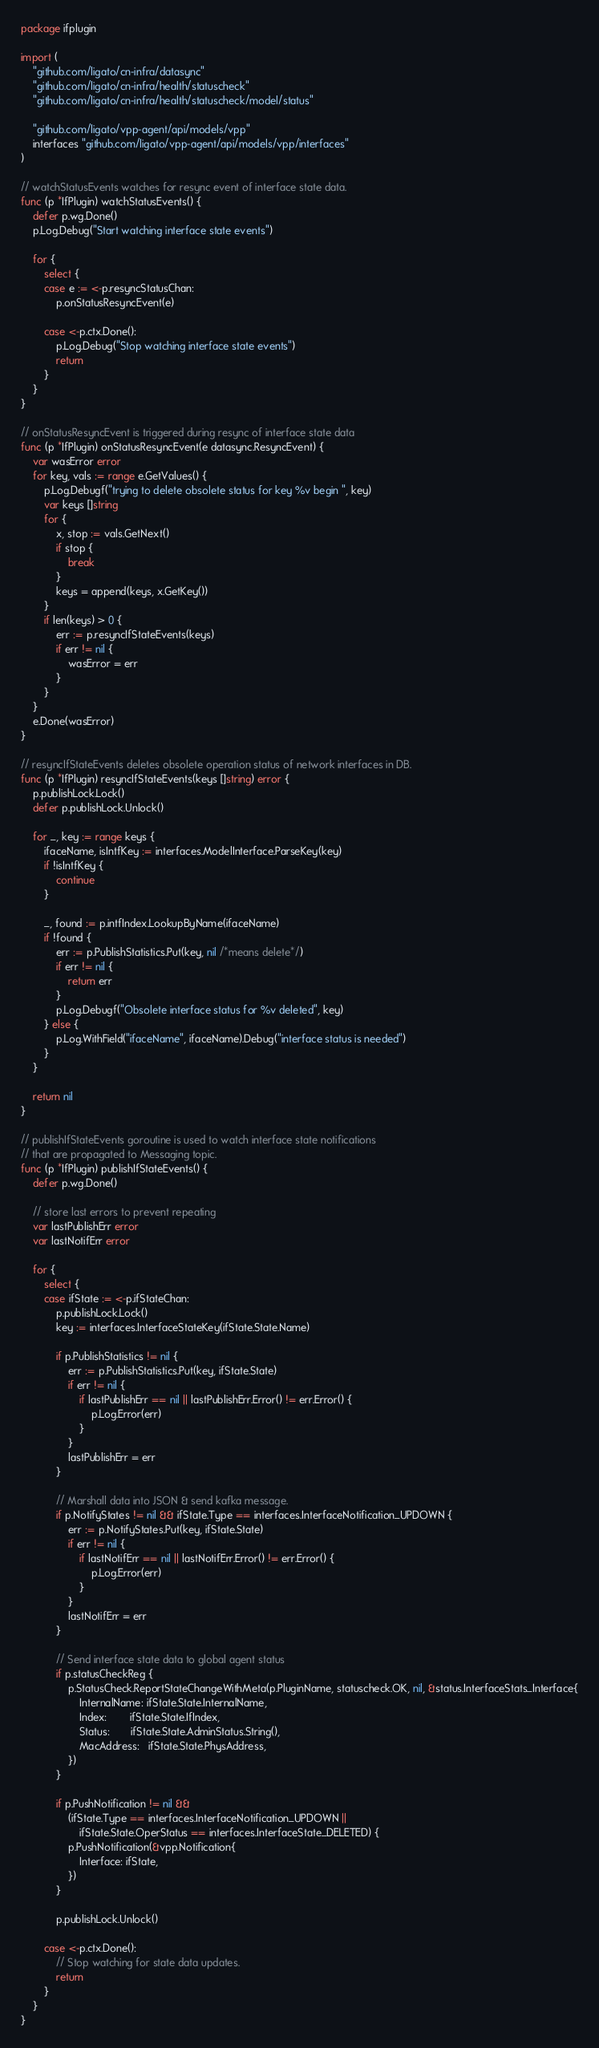Convert code to text. <code><loc_0><loc_0><loc_500><loc_500><_Go_>package ifplugin

import (
	"github.com/ligato/cn-infra/datasync"
	"github.com/ligato/cn-infra/health/statuscheck"
	"github.com/ligato/cn-infra/health/statuscheck/model/status"

	"github.com/ligato/vpp-agent/api/models/vpp"
	interfaces "github.com/ligato/vpp-agent/api/models/vpp/interfaces"
)

// watchStatusEvents watches for resync event of interface state data.
func (p *IfPlugin) watchStatusEvents() {
	defer p.wg.Done()
	p.Log.Debug("Start watching interface state events")

	for {
		select {
		case e := <-p.resyncStatusChan:
			p.onStatusResyncEvent(e)

		case <-p.ctx.Done():
			p.Log.Debug("Stop watching interface state events")
			return
		}
	}
}

// onStatusResyncEvent is triggered during resync of interface state data
func (p *IfPlugin) onStatusResyncEvent(e datasync.ResyncEvent) {
	var wasError error
	for key, vals := range e.GetValues() {
		p.Log.Debugf("trying to delete obsolete status for key %v begin ", key)
		var keys []string
		for {
			x, stop := vals.GetNext()
			if stop {
				break
			}
			keys = append(keys, x.GetKey())
		}
		if len(keys) > 0 {
			err := p.resyncIfStateEvents(keys)
			if err != nil {
				wasError = err
			}
		}
	}
	e.Done(wasError)
}

// resyncIfStateEvents deletes obsolete operation status of network interfaces in DB.
func (p *IfPlugin) resyncIfStateEvents(keys []string) error {
	p.publishLock.Lock()
	defer p.publishLock.Unlock()

	for _, key := range keys {
		ifaceName, isIntfKey := interfaces.ModelInterface.ParseKey(key)
		if !isIntfKey {
			continue
		}

		_, found := p.intfIndex.LookupByName(ifaceName)
		if !found {
			err := p.PublishStatistics.Put(key, nil /*means delete*/)
			if err != nil {
				return err
			}
			p.Log.Debugf("Obsolete interface status for %v deleted", key)
		} else {
			p.Log.WithField("ifaceName", ifaceName).Debug("interface status is needed")
		}
	}

	return nil
}

// publishIfStateEvents goroutine is used to watch interface state notifications
// that are propagated to Messaging topic.
func (p *IfPlugin) publishIfStateEvents() {
	defer p.wg.Done()

	// store last errors to prevent repeating
	var lastPublishErr error
	var lastNotifErr error

	for {
		select {
		case ifState := <-p.ifStateChan:
			p.publishLock.Lock()
			key := interfaces.InterfaceStateKey(ifState.State.Name)

			if p.PublishStatistics != nil {
				err := p.PublishStatistics.Put(key, ifState.State)
				if err != nil {
					if lastPublishErr == nil || lastPublishErr.Error() != err.Error() {
						p.Log.Error(err)
					}
				}
				lastPublishErr = err
			}

			// Marshall data into JSON & send kafka message.
			if p.NotifyStates != nil && ifState.Type == interfaces.InterfaceNotification_UPDOWN {
				err := p.NotifyStates.Put(key, ifState.State)
				if err != nil {
					if lastNotifErr == nil || lastNotifErr.Error() != err.Error() {
						p.Log.Error(err)
					}
				}
				lastNotifErr = err
			}

			// Send interface state data to global agent status
			if p.statusCheckReg {
				p.StatusCheck.ReportStateChangeWithMeta(p.PluginName, statuscheck.OK, nil, &status.InterfaceStats_Interface{
					InternalName: ifState.State.InternalName,
					Index:        ifState.State.IfIndex,
					Status:       ifState.State.AdminStatus.String(),
					MacAddress:   ifState.State.PhysAddress,
				})
			}

			if p.PushNotification != nil &&
				(ifState.Type == interfaces.InterfaceNotification_UPDOWN ||
					ifState.State.OperStatus == interfaces.InterfaceState_DELETED) {
				p.PushNotification(&vpp.Notification{
					Interface: ifState,
				})
			}

			p.publishLock.Unlock()

		case <-p.ctx.Done():
			// Stop watching for state data updates.
			return
		}
	}
}
</code> 